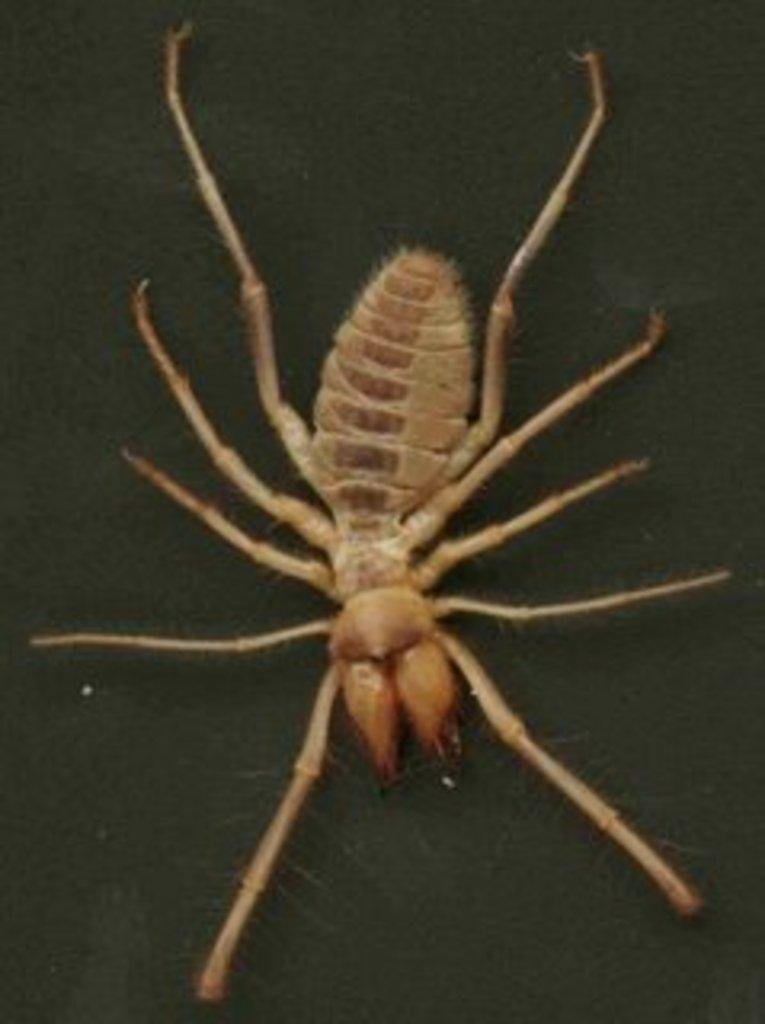What type of animal is in the picture? There is a sun spider in the picture. What color is the background of the image? The background of the image is black. What type of whip can be seen in the image? There is no whip present in the image; it features a sun spider against a black background. How many circles are visible in the image? There are no circles visible in the image; it only contains a sun spider and a black background. 